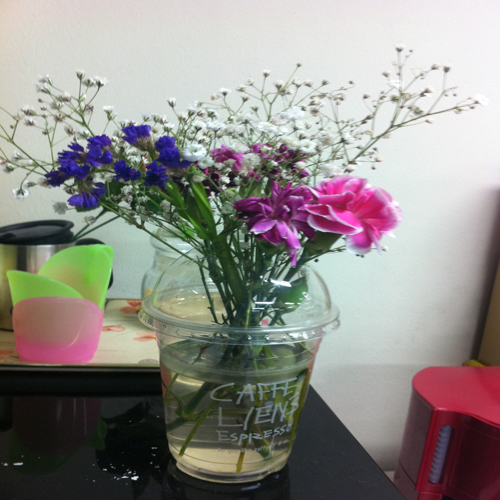Can you tell me what types of flowers are in the arrangement? The arrangement includes pink carnations and blue flowers that resemble cornflowers, as well as clusters of baby's breath which add a delicate touch to the composition. 